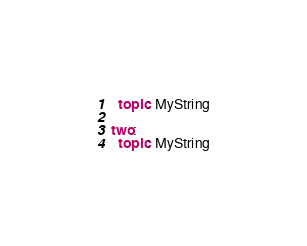Convert code to text. <code><loc_0><loc_0><loc_500><loc_500><_YAML_>  topic: MyString

two:
  topic: MyString
</code> 